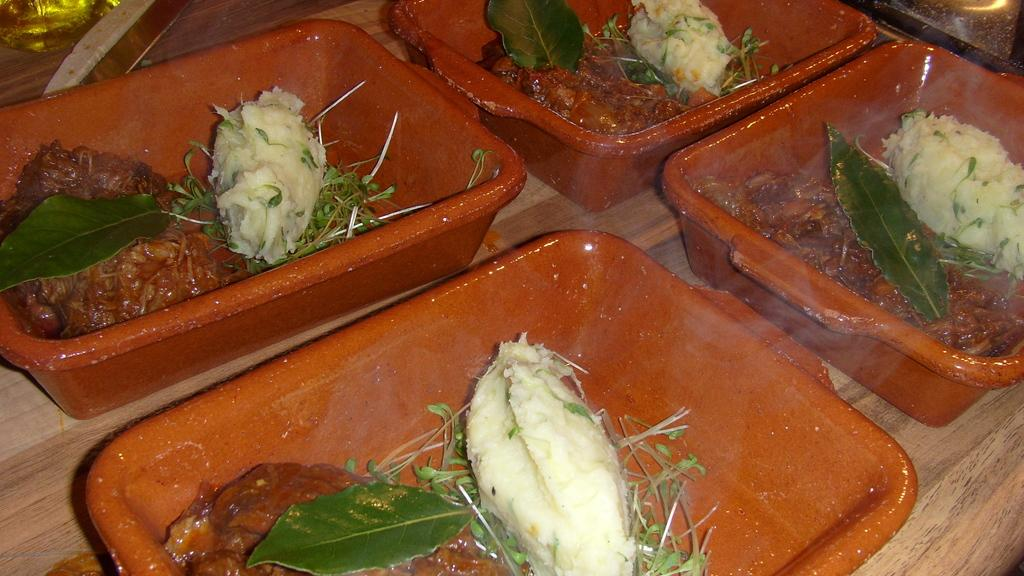What type of objects are in the image? There are food items in the image. How are the food items arranged or organized? The food items are in trays. Where are the trays with food items located? The trays are on a table. What is the primary focus of the image? The food items and trays are in the center of the image. What type of paper is being used to write down ideas in the image? There is no paper or writing present in the image; it only features food items in trays on a table. How many ducks are visible in the image? There are no ducks present in the image. 